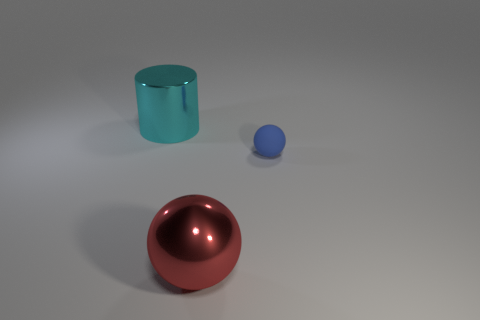Are there any other things that have the same shape as the cyan object?
Provide a short and direct response. No. Is the number of shiny spheres that are to the left of the big red metal ball less than the number of large cyan matte cylinders?
Give a very brief answer. No. What shape is the metal thing that is behind the big object on the right side of the object behind the tiny blue matte thing?
Ensure brevity in your answer.  Cylinder. Are there more big cyan shiny cylinders than large cyan shiny cubes?
Your response must be concise. Yes. What number of other objects are the same material as the blue object?
Offer a very short reply. 0. What number of objects are either cylinders or large objects in front of the cyan metallic cylinder?
Provide a succinct answer. 2. Is the number of big red shiny things less than the number of purple matte cubes?
Provide a short and direct response. No. What is the color of the metal object right of the big object left of the thing that is in front of the tiny blue rubber thing?
Make the answer very short. Red. Do the small blue sphere and the cyan cylinder have the same material?
Your answer should be very brief. No. There is a large cyan metal thing; what number of shiny spheres are right of it?
Offer a very short reply. 1. 